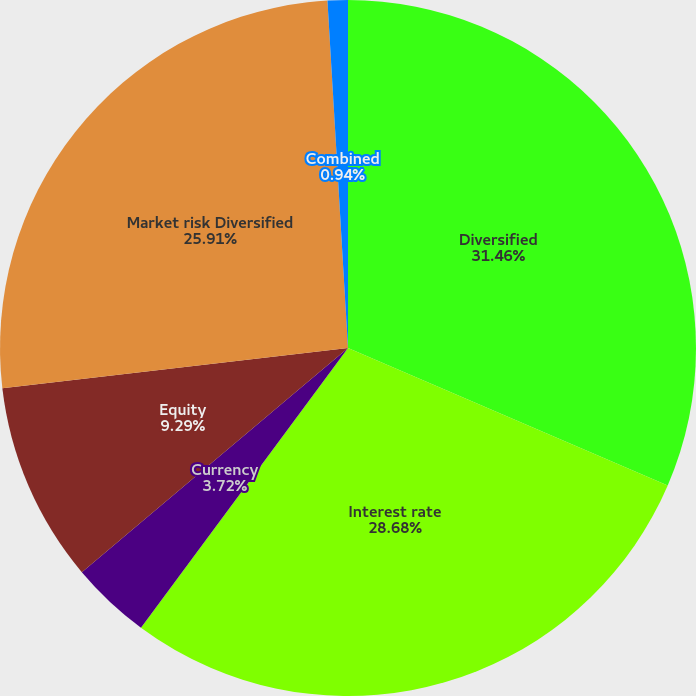Convert chart. <chart><loc_0><loc_0><loc_500><loc_500><pie_chart><fcel>Diversified<fcel>Interest rate<fcel>Currency<fcel>Equity<fcel>Market risk Diversified<fcel>Combined<nl><fcel>31.46%<fcel>28.68%<fcel>3.72%<fcel>9.29%<fcel>25.91%<fcel>0.94%<nl></chart> 